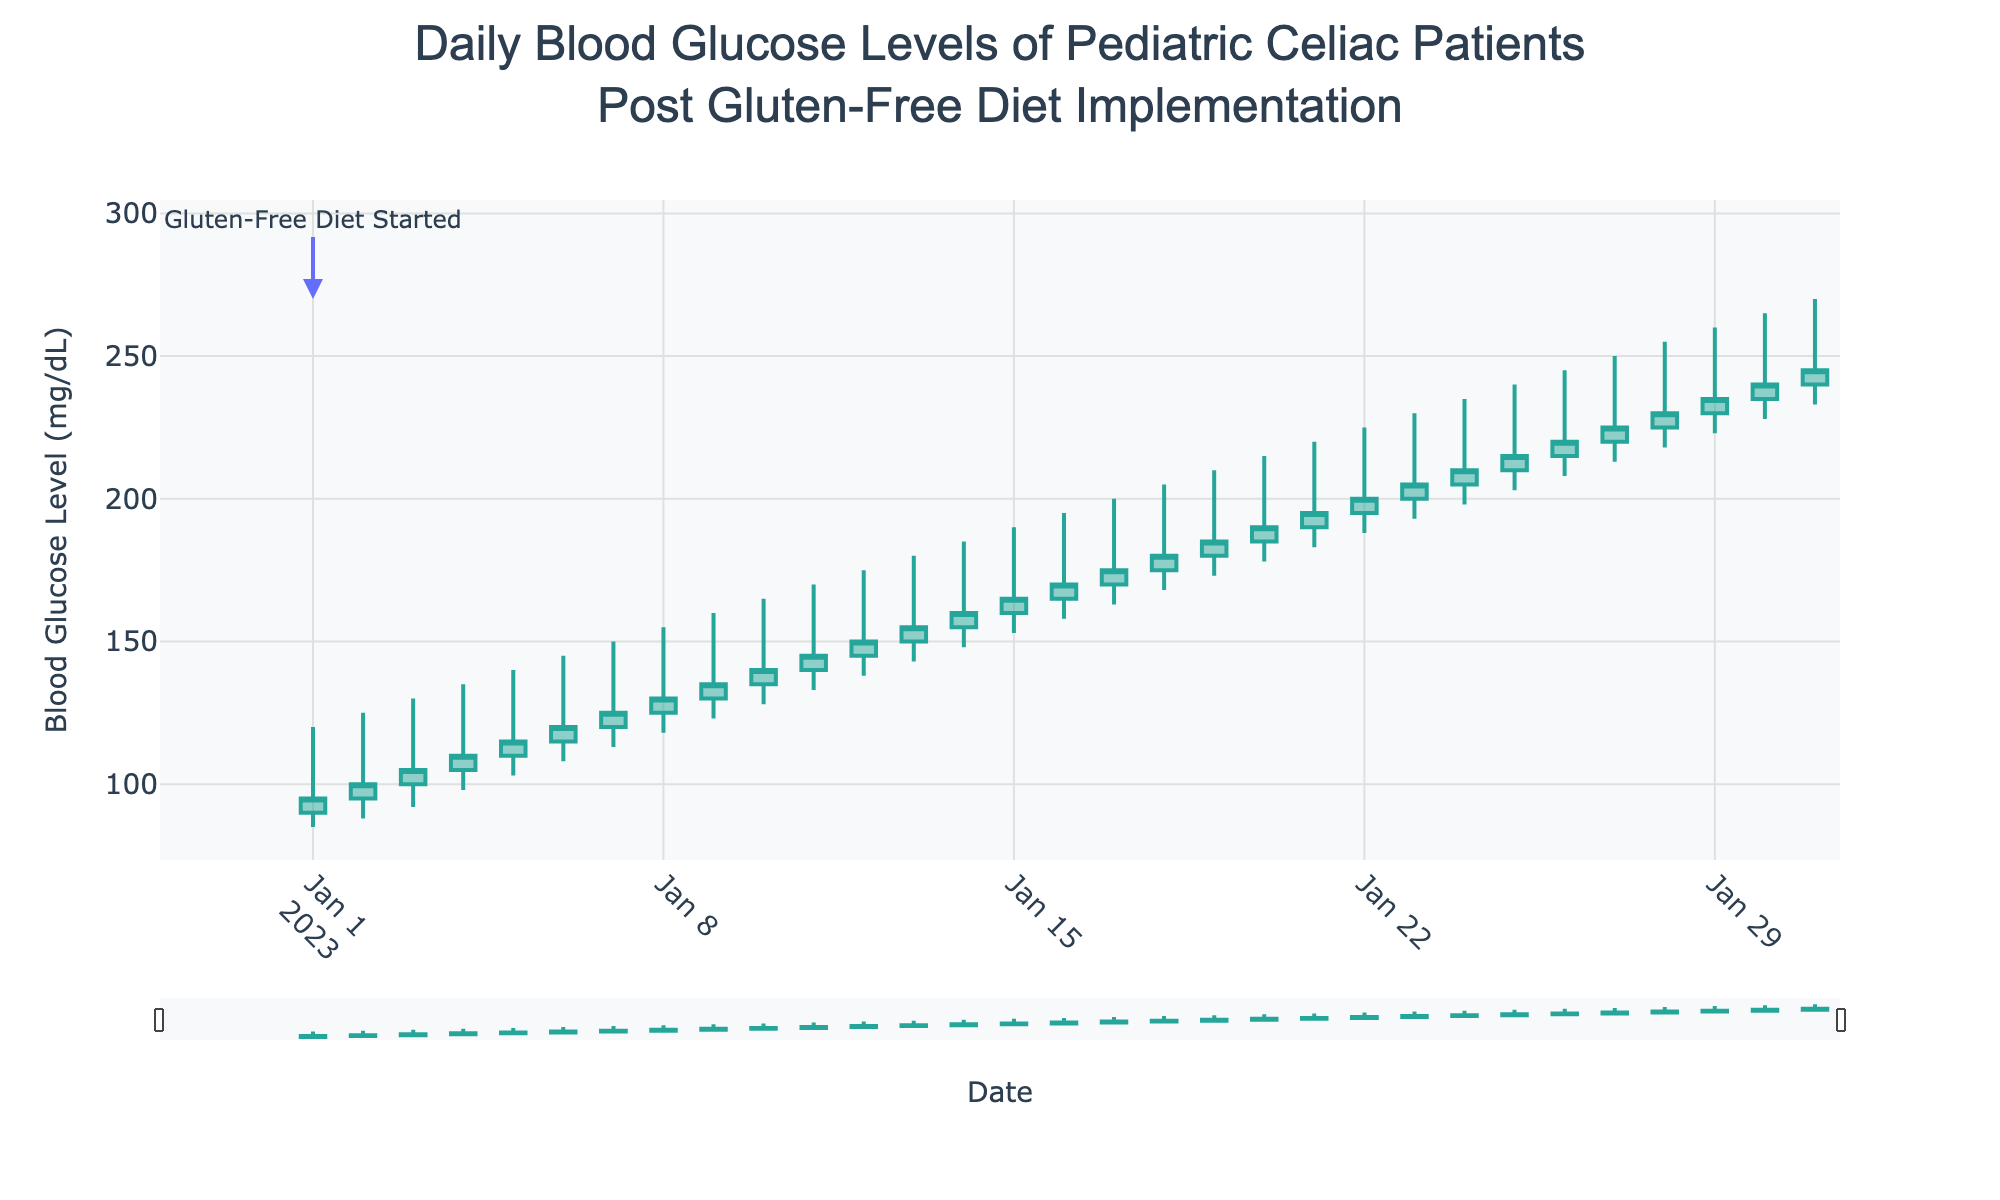What's the title of the plot? The title is located at the top center of the figure.
Answer: Daily Blood Glucose Levels of Pediatric Celiac Patients Post Gluten-Free Diet Implementation What is represented on the x-axis? The x-axis shows the recording dates for blood glucose levels.
Answer: Date What is the range of blood glucose levels from January 1st to January 31st? By looking at the lowest and highest points on the y-axis, the range can be identified between 85 and 270 mg/dL.
Answer: 85-270 mg/dL How did the opening blood glucose level change from January 1st to January 31st? The opening glucose level on January 1st was 90 mg/dL, and it increased steadily to 240 mg/dL by January 31st.
Answer: Increased from 90 to 240 mg/dL What was the highest blood glucose level recorded during the month? The highest point indicated by the top of the wicks shows the peak level.
Answer: 270 mg/dL How many data points are represented in the plot? By counting the candlesticks, there is one for each day from January 1st to January 31st.
Answer: 31 Which day had the biggest range between high and low blood glucose levels? By inspecting the length of the wicks, January 31st had the highest range from 265 to 233 mg/dL.
Answer: January 31st On which date did the blood glucose level close at 165 mg/dL? The closing value can be found on January 15th.
Answer: January 15 What’s the average high blood glucose level recorded over the first week? Add the high values of the first 7 days (120 + 125 + 130 + 135 + 140 + 145 + 150) and divide by 7. Sum = 945, Average = 945/7 ≈ 135 mg/dL.
Answer: 135 mg/dL Which dates show a decrease in closing blood glucose levels compared to the previous day? Look for dates where the close value is less than the previous day's close. These are January 2nd, 3rd, and 4th.
Answer: January 2nd, 3rd, and 4th 